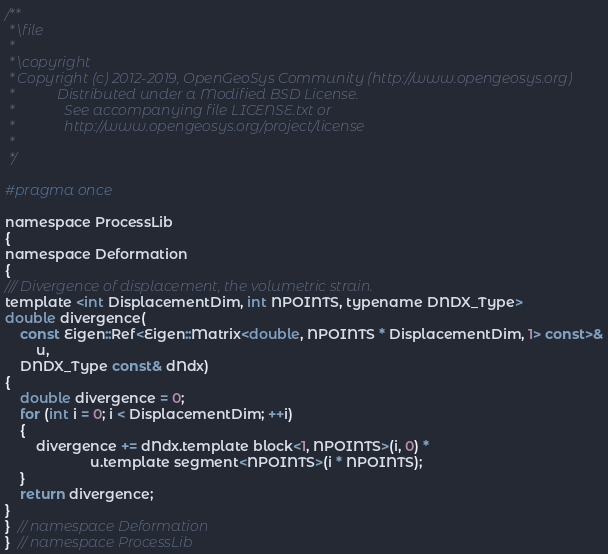<code> <loc_0><loc_0><loc_500><loc_500><_C_>/**
 * \file
 *
 * \copyright
 * Copyright (c) 2012-2019, OpenGeoSys Community (http://www.opengeosys.org)
 *            Distributed under a Modified BSD License.
 *              See accompanying file LICENSE.txt or
 *              http://www.opengeosys.org/project/license
 *
 */

#pragma once

namespace ProcessLib
{
namespace Deformation
{
/// Divergence of displacement, the volumetric strain.
template <int DisplacementDim, int NPOINTS, typename DNDX_Type>
double divergence(
    const Eigen::Ref<Eigen::Matrix<double, NPOINTS * DisplacementDim, 1> const>&
        u,
    DNDX_Type const& dNdx)
{
    double divergence = 0;
    for (int i = 0; i < DisplacementDim; ++i)
    {
        divergence += dNdx.template block<1, NPOINTS>(i, 0) *
                      u.template segment<NPOINTS>(i * NPOINTS);
    }
    return divergence;
}
}  // namespace Deformation
}  // namespace ProcessLib
</code> 